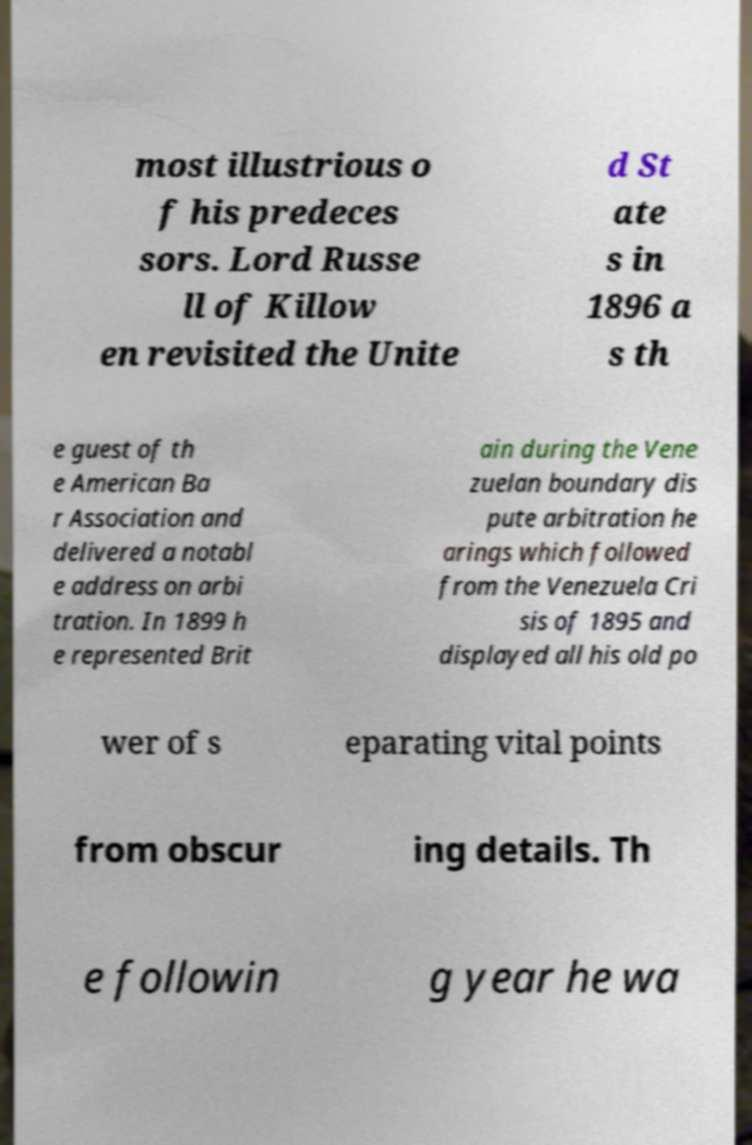For documentation purposes, I need the text within this image transcribed. Could you provide that? most illustrious o f his predeces sors. Lord Russe ll of Killow en revisited the Unite d St ate s in 1896 a s th e guest of th e American Ba r Association and delivered a notabl e address on arbi tration. In 1899 h e represented Brit ain during the Vene zuelan boundary dis pute arbitration he arings which followed from the Venezuela Cri sis of 1895 and displayed all his old po wer of s eparating vital points from obscur ing details. Th e followin g year he wa 